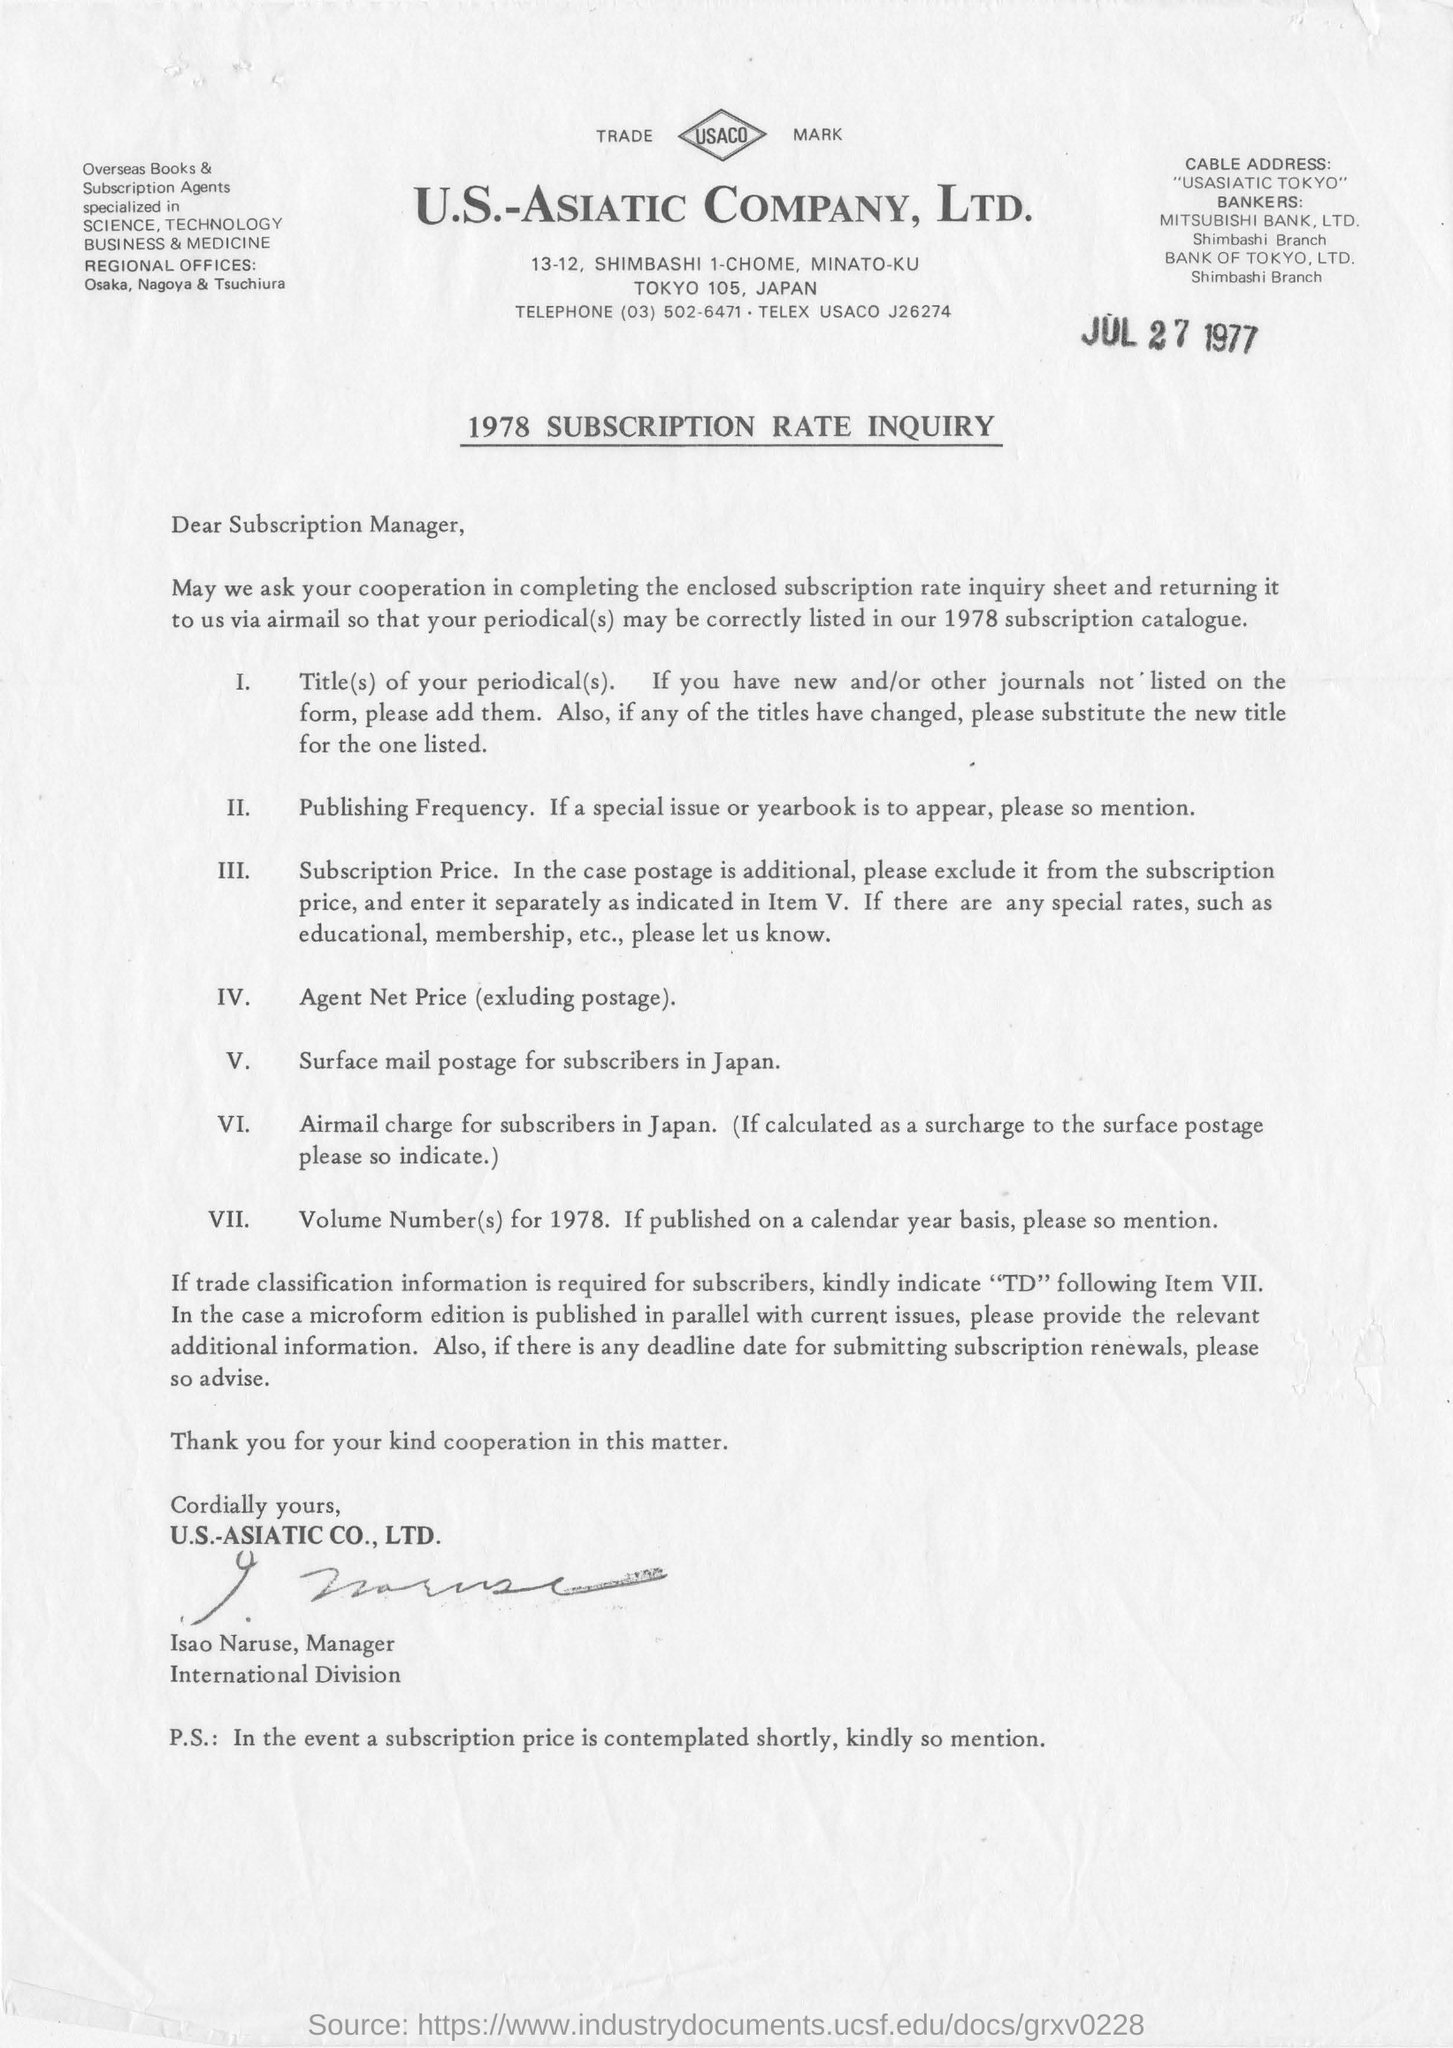Who has signed  the letter ?
Make the answer very short. Isao Naruse. To whom this letter was written ?
Keep it short and to the point. Subscription manager. In which year this letter was published ?
Your response must be concise. Jul 27  1977. What is the name of the company
Make the answer very short. U.S.-ASIATIC COMPANY, Ltd. What is written in cable address ?
Offer a very short reply. "USASIATIC TOKYO". What is the telephone number of the given company ?
Make the answer very short. (03) 502-6471. 